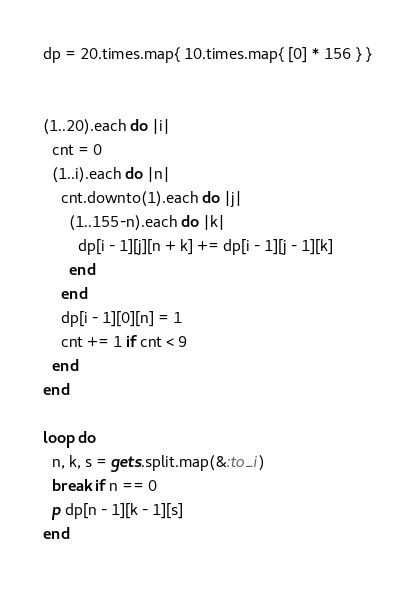<code> <loc_0><loc_0><loc_500><loc_500><_Ruby_>dp = 20.times.map{ 10.times.map{ [0] * 156 } }


(1..20).each do |i|
  cnt = 0
  (1..i).each do |n|
    cnt.downto(1).each do |j|
      (1..155-n).each do |k|
        dp[i - 1][j][n + k] += dp[i - 1][j - 1][k]
      end
    end
    dp[i - 1][0][n] = 1
    cnt += 1 if cnt < 9
  end
end

loop do
  n, k, s = gets.split.map(&:to_i)
  break if n == 0
  p dp[n - 1][k - 1][s]
end</code> 